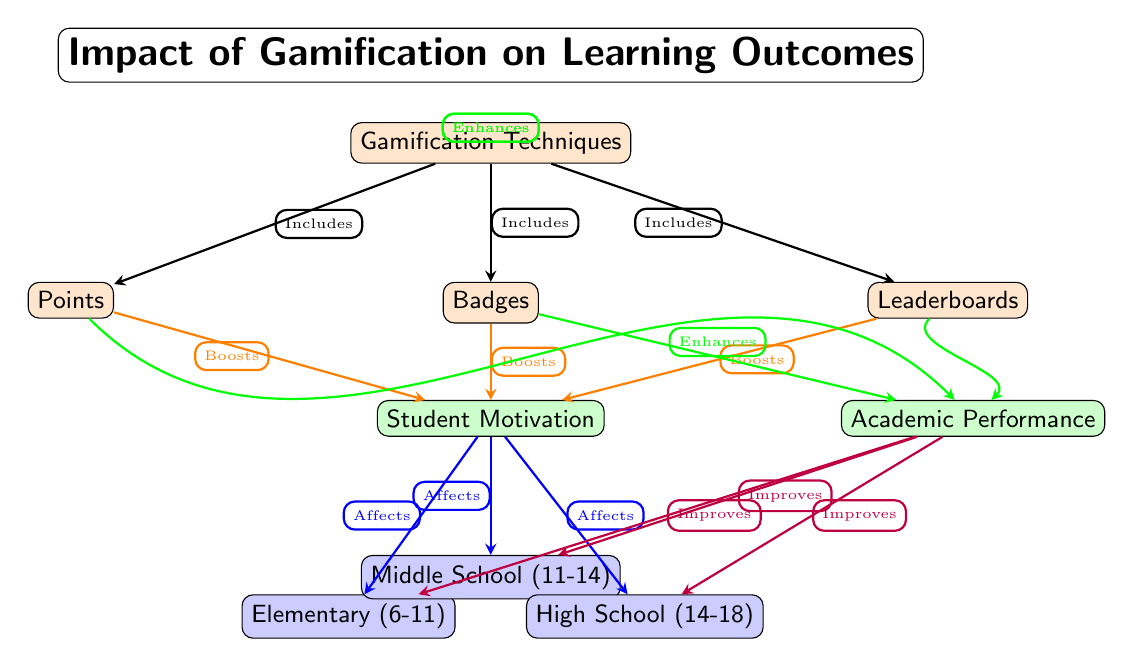What are the three gamification techniques listed? The diagram shows three gamification techniques: Points, Badges, and Leaderboards. These are represented as nodes connected to the central node labeled "Gamification Techniques."
Answer: Points, Badges, Leaderboards What is the primary effect of points on student motivation? According to the diagram, points are shown to have the effect of boosting student motivation. This is indicated by the arrow that connects the Points node to the Student Motivation node with the label "Boosts."
Answer: Boosts Which age group is most directly affected by motivation? The diagram indicates that student motivation affects three age groups: Elementary, Middle School, and High School. However, all three age groups are equally affected, i.e., motivation affects each age group equally.
Answer: Elementary, Middle School, High School How do badges affect academic performance? From the diagram, badges enhance academic performance, as indicated by the arrow connecting the Badges node to the Academic Performance node, labeled "Enhances." This relationship signifies a positive influence on performance through the use of badges.
Answer: Enhances What is the relationship between academic performance and the age groups? The diagram illustrates that academic performance improves across all age groups: Elementary, Middle School, and High School. This is shown by arrows leading from the Academic Performance node to each of the age group nodes, all labeled "Improves."
Answer: Improves Which gamification technique impacts both motivation and academic performance? All three techniques—Points, Badges, and Leaderboards—connect to both motivation and academic performance, implying that they all influence both outcomes. The diagram does not isolate any one technique as uniquely impactful to both.
Answer: Points, Badges, Leaderboards What happens to student motivation in each age group according to the diagram? The diagram shows that student motivation's impact extends to all three age groups (Elementary, Middle School, High School), indicating that motivation affects students uniformly across these ages.
Answer: Affects What is the visual representation's title? The title of the diagram is prominently displayed at the top, stating "Impact of Gamification on Learning Outcomes," which summarizes the overall focus of the content depicted in the diagram.
Answer: Impact of Gamification on Learning Outcomes 